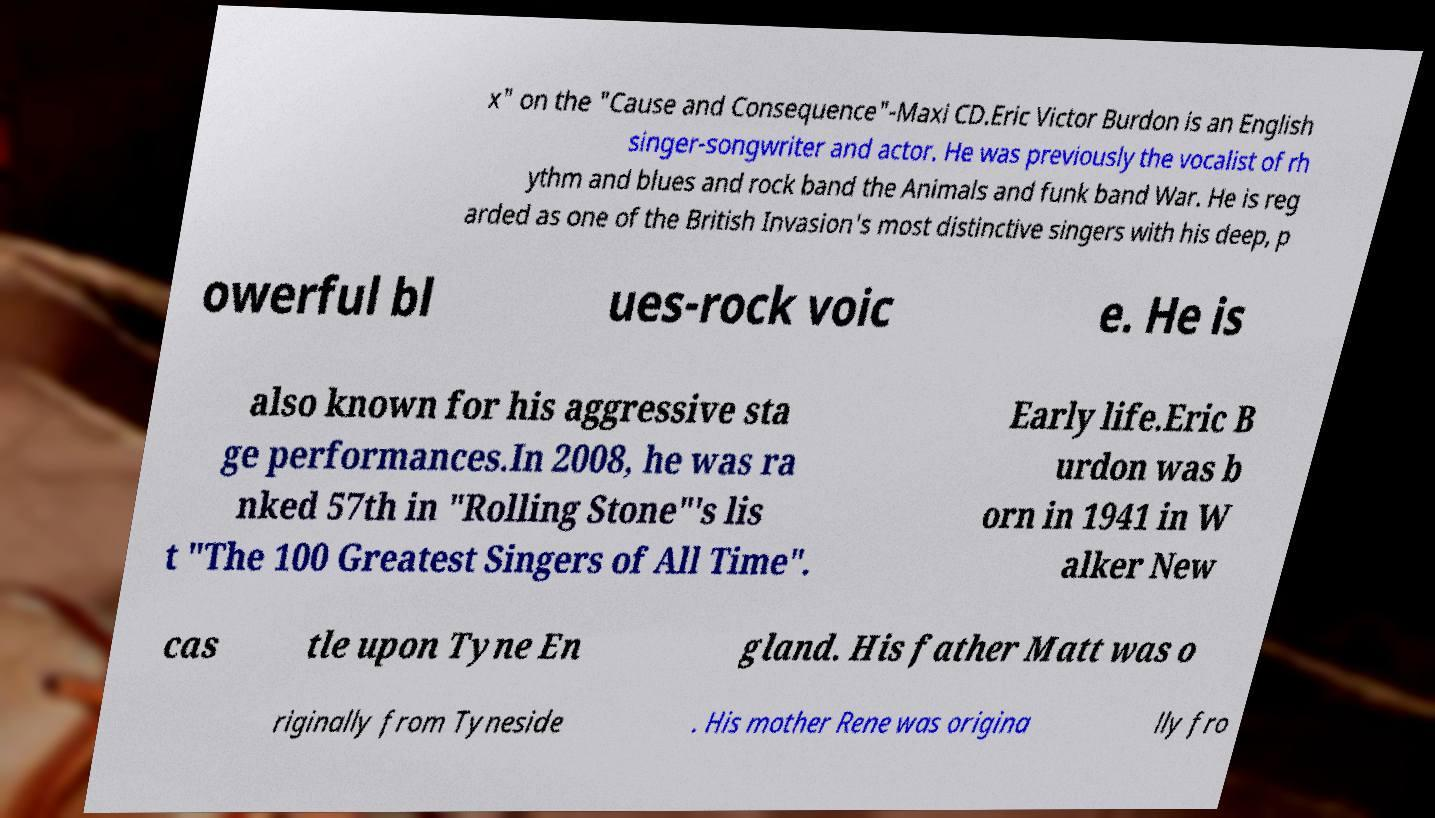I need the written content from this picture converted into text. Can you do that? x" on the "Cause and Consequence"-Maxi CD.Eric Victor Burdon is an English singer-songwriter and actor. He was previously the vocalist of rh ythm and blues and rock band the Animals and funk band War. He is reg arded as one of the British Invasion's most distinctive singers with his deep, p owerful bl ues-rock voic e. He is also known for his aggressive sta ge performances.In 2008, he was ra nked 57th in "Rolling Stone"'s lis t "The 100 Greatest Singers of All Time". Early life.Eric B urdon was b orn in 1941 in W alker New cas tle upon Tyne En gland. His father Matt was o riginally from Tyneside . His mother Rene was origina lly fro 